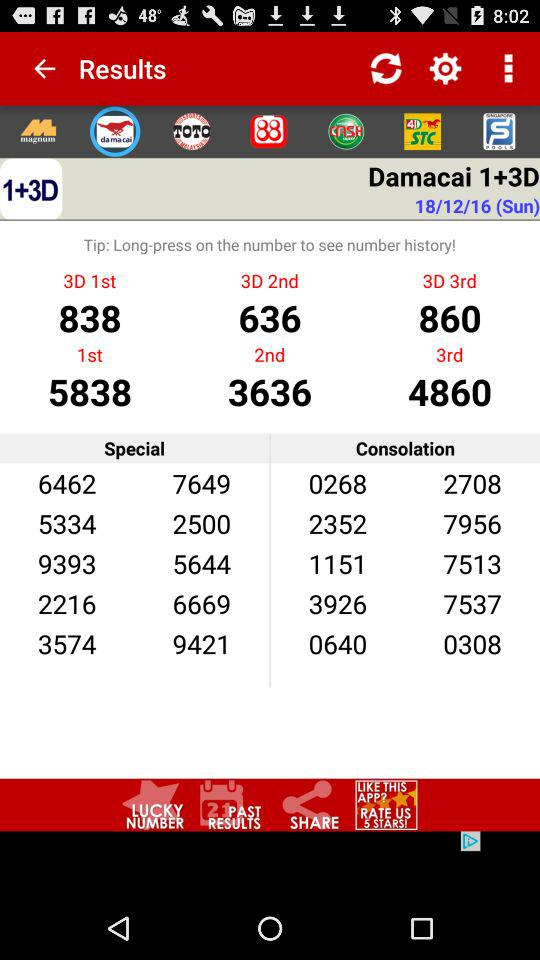What is the day of the given date? The day is Sunday. 